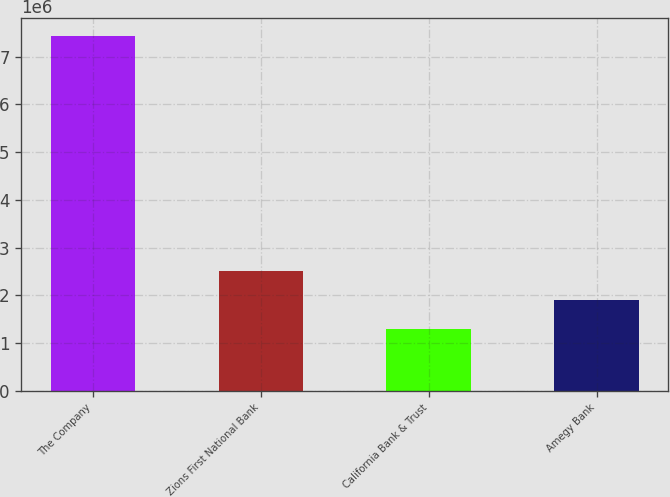Convert chart. <chart><loc_0><loc_0><loc_500><loc_500><bar_chart><fcel>The Company<fcel>Zions First National Bank<fcel>California Bank & Trust<fcel>Amegy Bank<nl><fcel>7.4433e+06<fcel>2.51754e+06<fcel>1.2861e+06<fcel>1.90182e+06<nl></chart> 